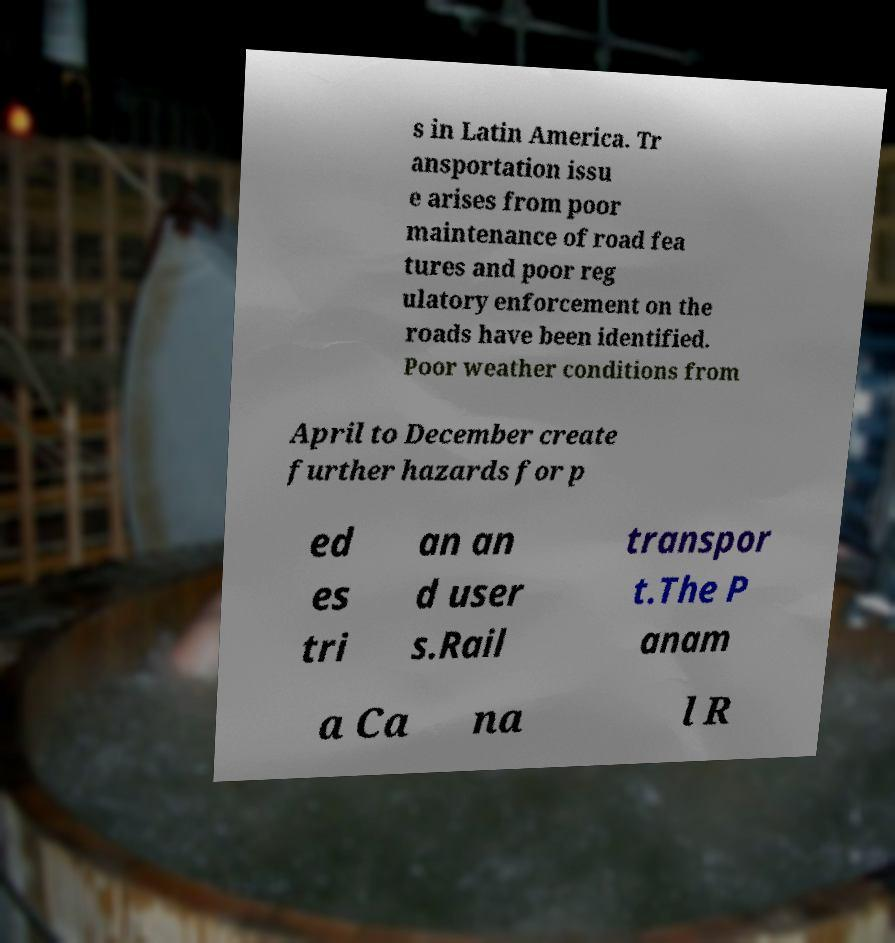For documentation purposes, I need the text within this image transcribed. Could you provide that? s in Latin America. Tr ansportation issu e arises from poor maintenance of road fea tures and poor reg ulatory enforcement on the roads have been identified. Poor weather conditions from April to December create further hazards for p ed es tri an an d user s.Rail transpor t.The P anam a Ca na l R 